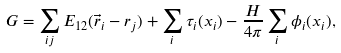Convert formula to latex. <formula><loc_0><loc_0><loc_500><loc_500>G = \sum _ { i j } E _ { 1 2 } ( \vec { r } _ { i } - { r } _ { j } ) + \sum _ { i } \tau _ { i } ( x _ { i } ) - \frac { H } { 4 \pi } \sum _ { i } \phi _ { i } ( x _ { i } ) ,</formula> 